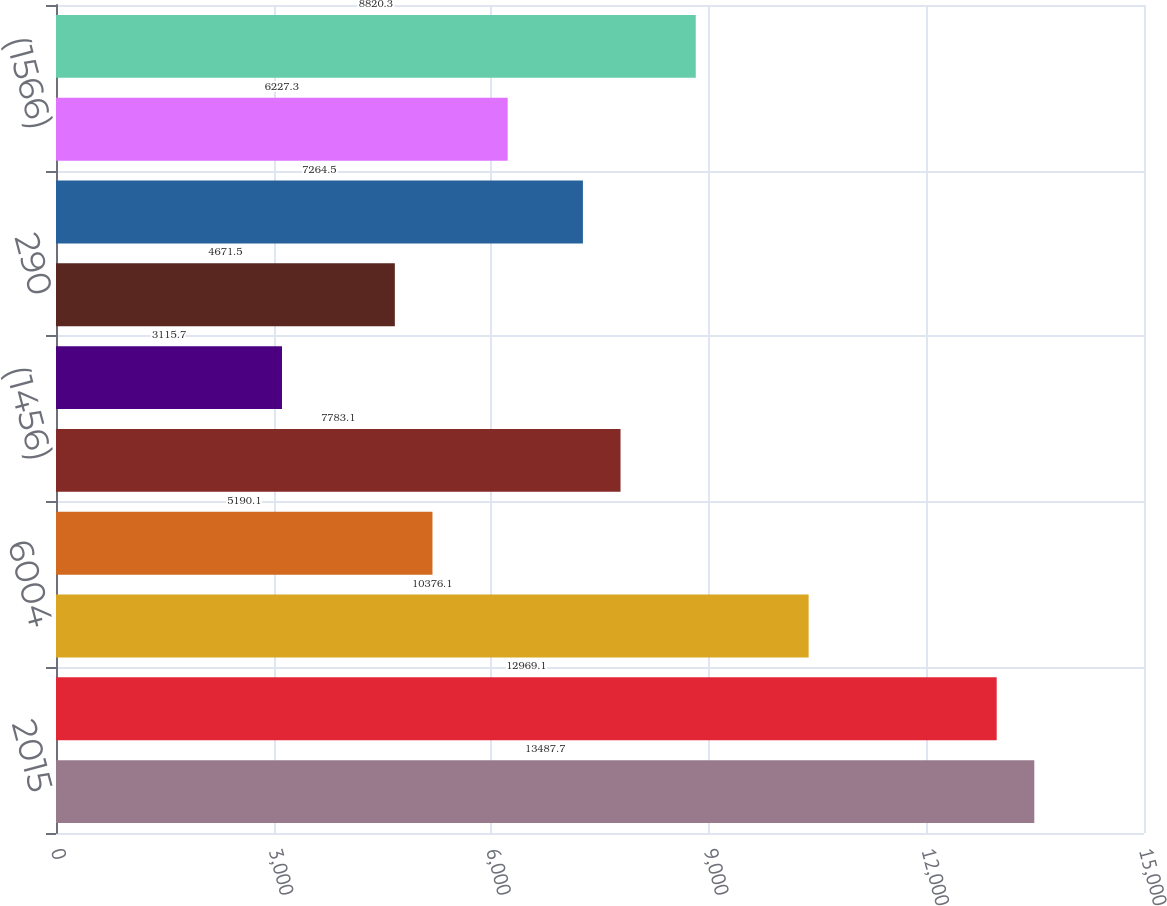<chart> <loc_0><loc_0><loc_500><loc_500><bar_chart><fcel>2015<fcel>35932<fcel>6004<fcel>1614<fcel>(1456)<fcel>822<fcel>290<fcel>(1744)<fcel>(1566)<fcel>742<nl><fcel>13487.7<fcel>12969.1<fcel>10376.1<fcel>5190.1<fcel>7783.1<fcel>3115.7<fcel>4671.5<fcel>7264.5<fcel>6227.3<fcel>8820.3<nl></chart> 